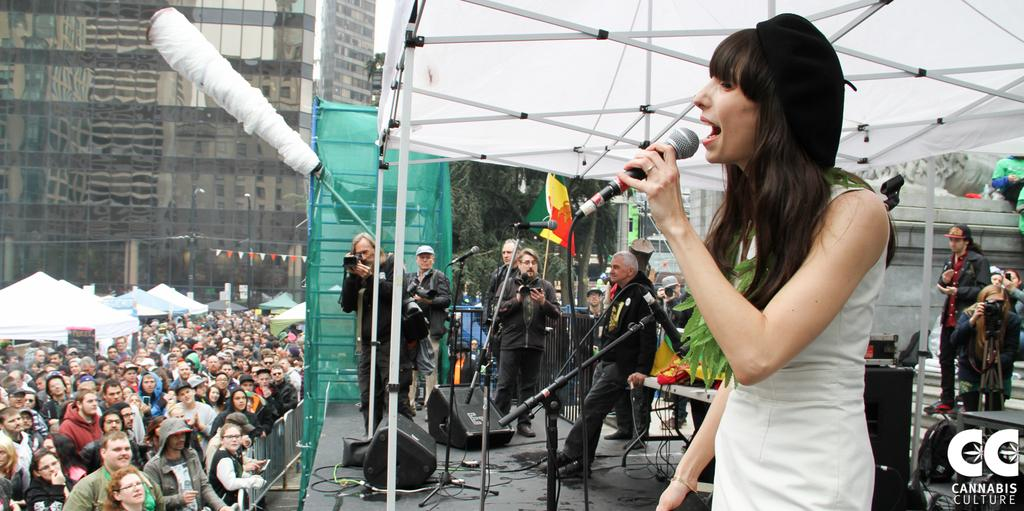What is the woman in the image holding? The woman is holding a microphone. What can be seen in the background of the image? There is a group of people, a tent, a building, a speaker, a piano, a tree, and a flag in the background of the image. Can you see a kitten playing under the piano in the image? There is no kitten present in the image, and the piano is not shown in a way that would allow us to see under it. 